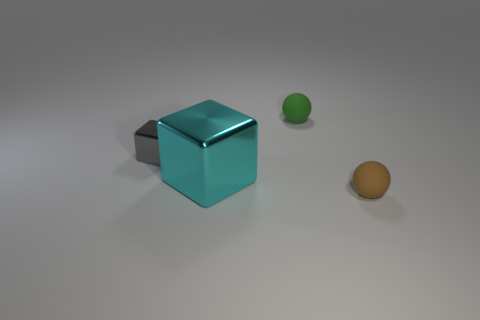There is a gray block that is the same material as the large cyan block; what is its size?
Your answer should be compact. Small. The brown rubber ball has what size?
Your answer should be compact. Small. What material is the small gray block?
Make the answer very short. Metal. Is the size of the matte object in front of the green ball the same as the small gray object?
Keep it short and to the point. Yes. How many objects are either small green rubber spheres or big cyan metallic blocks?
Provide a short and direct response. 2. What size is the object that is behind the cyan metallic object and to the right of the big metallic block?
Offer a terse response. Small. How many large green rubber objects are there?
Your answer should be compact. 0. What number of balls are either matte things or tiny blue matte things?
Make the answer very short. 2. There is a tiny matte object that is behind the sphere right of the tiny green thing; how many large metallic blocks are behind it?
Your response must be concise. 0. The matte object that is the same size as the green matte ball is what color?
Give a very brief answer. Brown. 